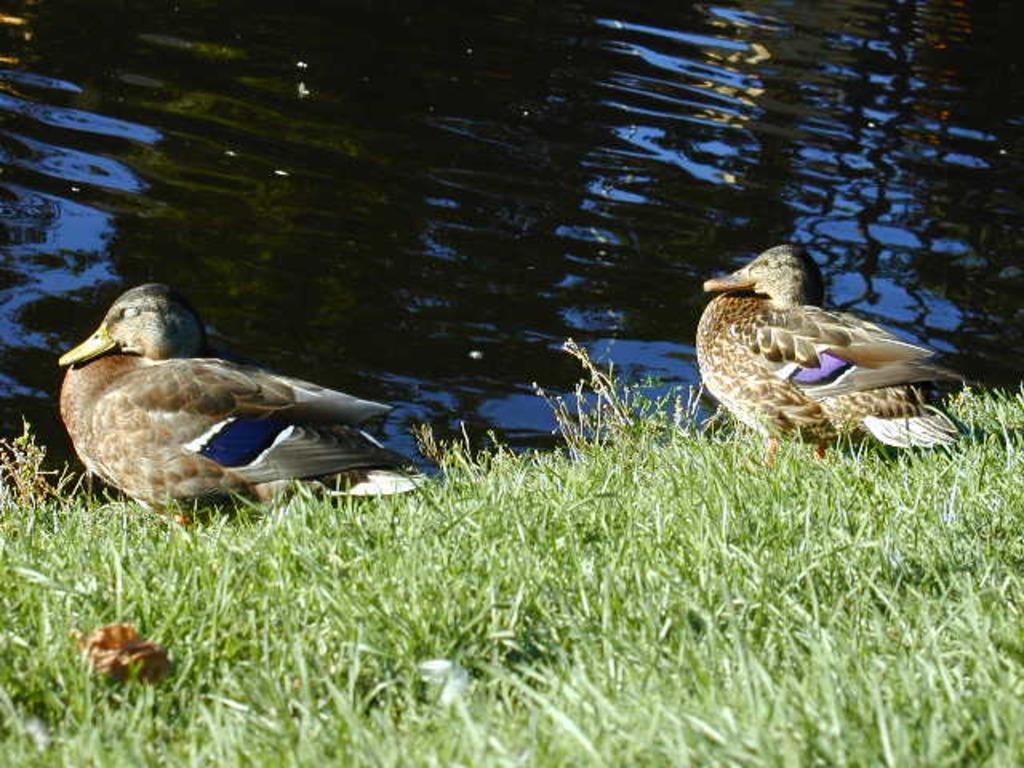Describe this image in one or two sentences. In the picture I can see two birds and the grass. In the background I can see the water. 